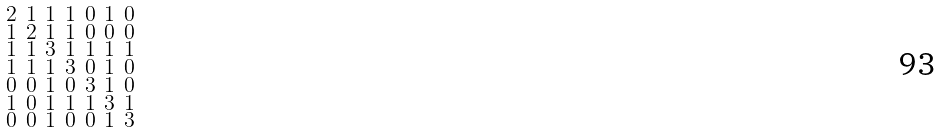<formula> <loc_0><loc_0><loc_500><loc_500>\begin{smallmatrix} 2 & 1 & 1 & 1 & 0 & 1 & 0 \\ 1 & 2 & 1 & 1 & 0 & 0 & 0 \\ 1 & 1 & 3 & 1 & 1 & 1 & 1 \\ 1 & 1 & 1 & 3 & 0 & 1 & 0 \\ 0 & 0 & 1 & 0 & 3 & 1 & 0 \\ 1 & 0 & 1 & 1 & 1 & 3 & 1 \\ 0 & 0 & 1 & 0 & 0 & 1 & 3 \end{smallmatrix}</formula> 